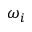<formula> <loc_0><loc_0><loc_500><loc_500>\omega _ { i }</formula> 